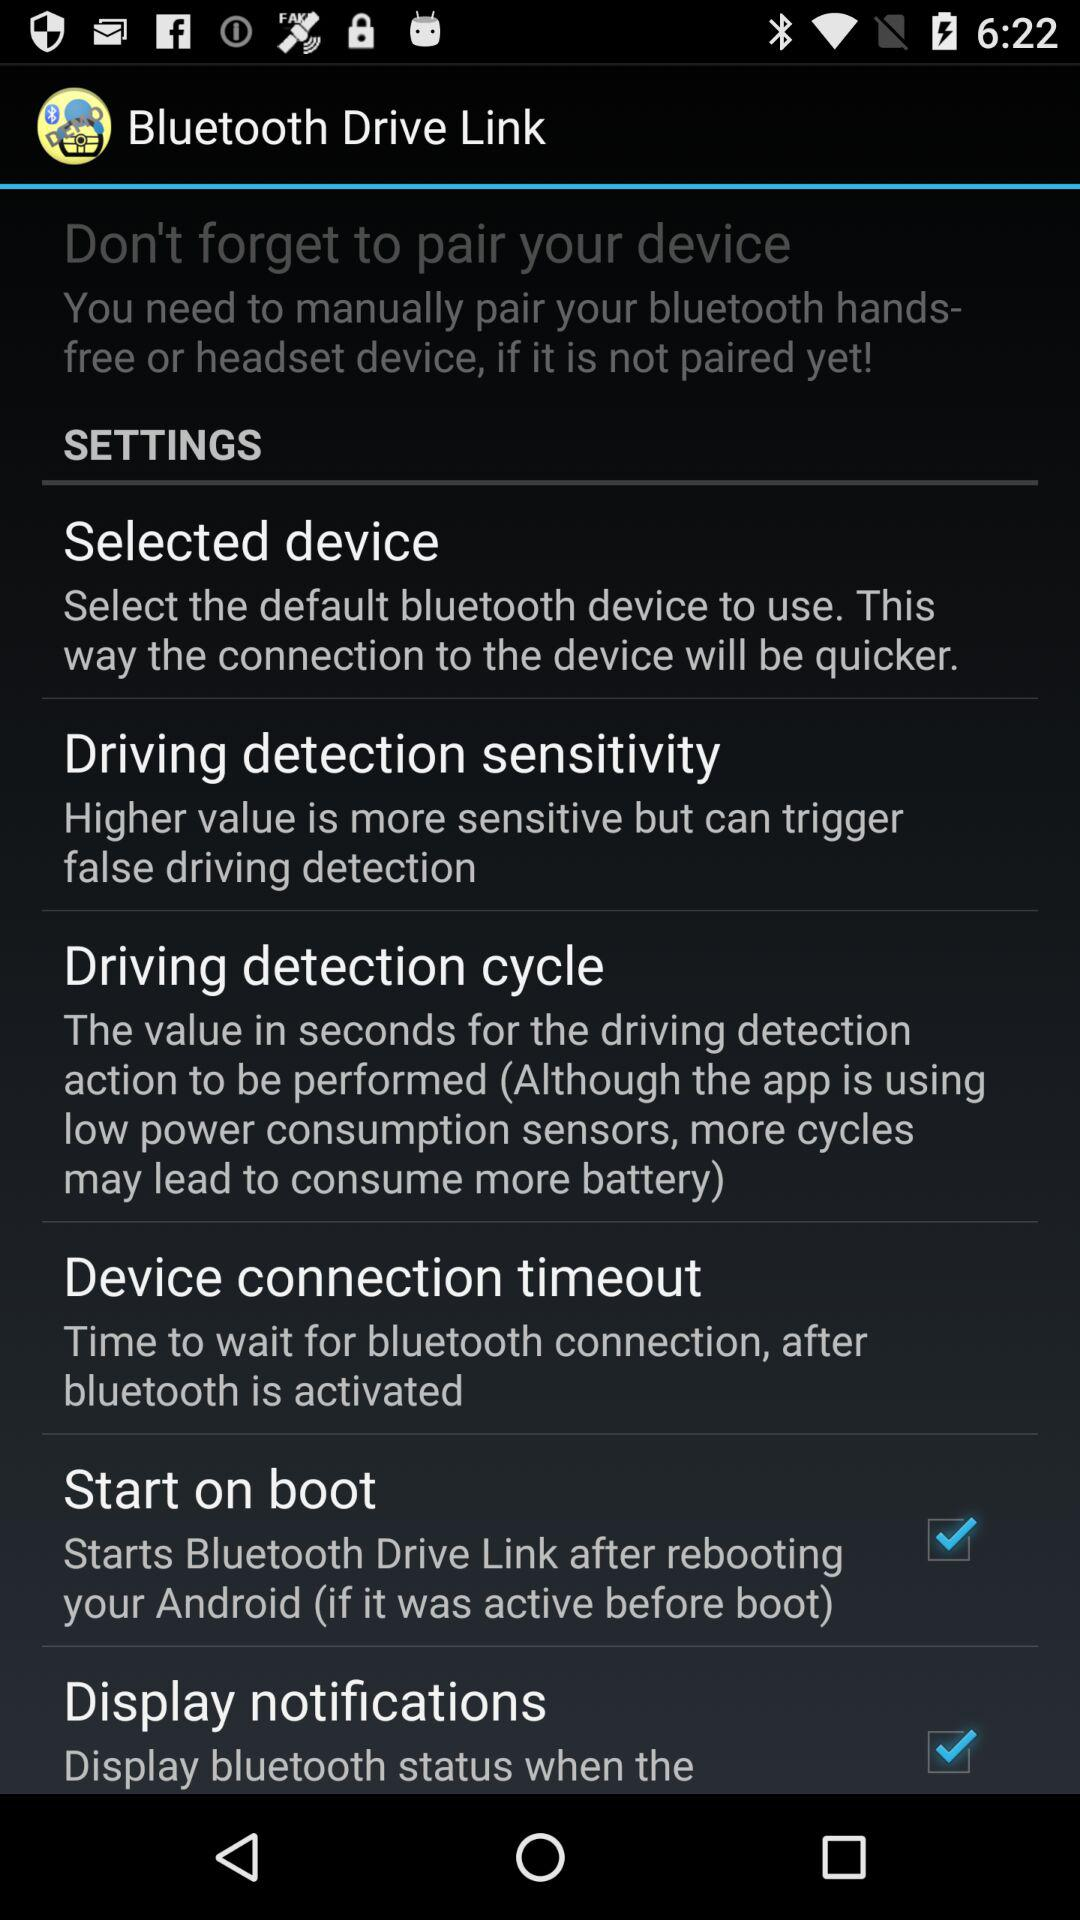How to select a device?
When the provided information is insufficient, respond with <no answer>. <no answer> 